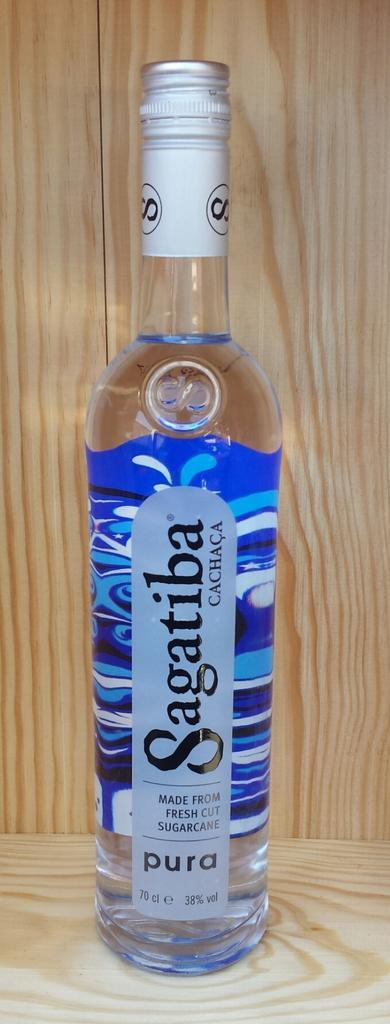In one or two sentences, can you explain what this image depicts? This picture seems to be of inside. In the center there is a sealed glass bottle placed on the top of the surface and in the background there is some wood. 